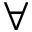<formula> <loc_0><loc_0><loc_500><loc_500>\forall</formula> 